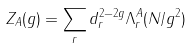<formula> <loc_0><loc_0><loc_500><loc_500>Z _ { A } ( g ) = \sum _ { r } d _ { r } ^ { 2 - 2 g } \Lambda _ { r } ^ { A } ( N / g ^ { 2 } )</formula> 